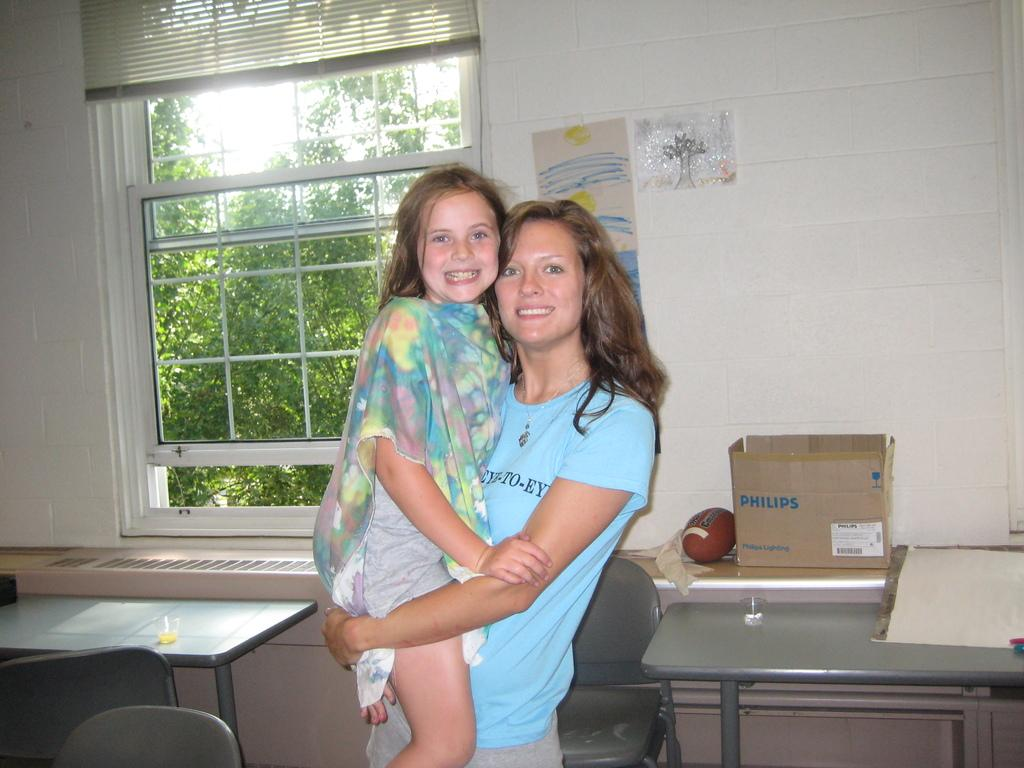What is the woman in the image wearing? The woman is wearing a blue dress in the image. What is the woman doing with the kid in the image? The woman is carrying a kid with her hands in the image. What type of furniture can be seen in the background of the image? There are tables and chairs in the background of the image. What is visible through the window in the background of the image? Unfortunately, the facts provided do not mention what can be seen through the window. What type of shop can be seen in the image? There is no shop present in the image. What type of meeting is taking place in the image? There is no meeting taking place in the image. 